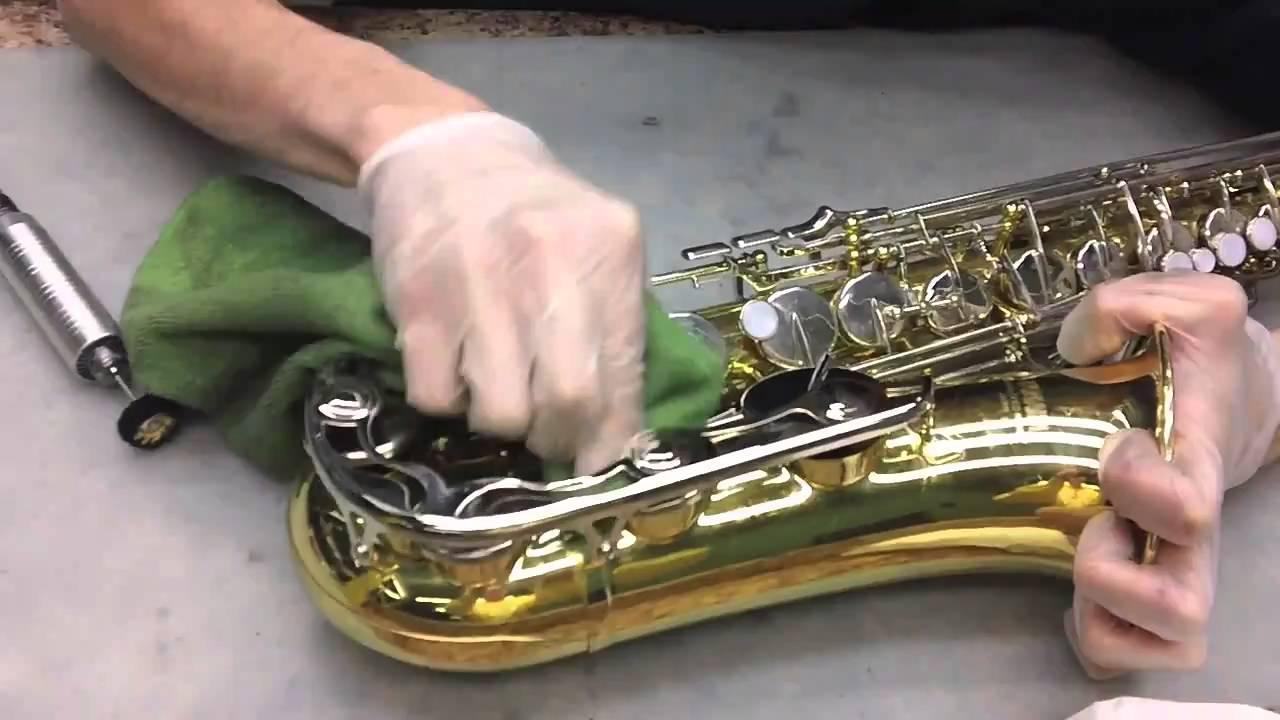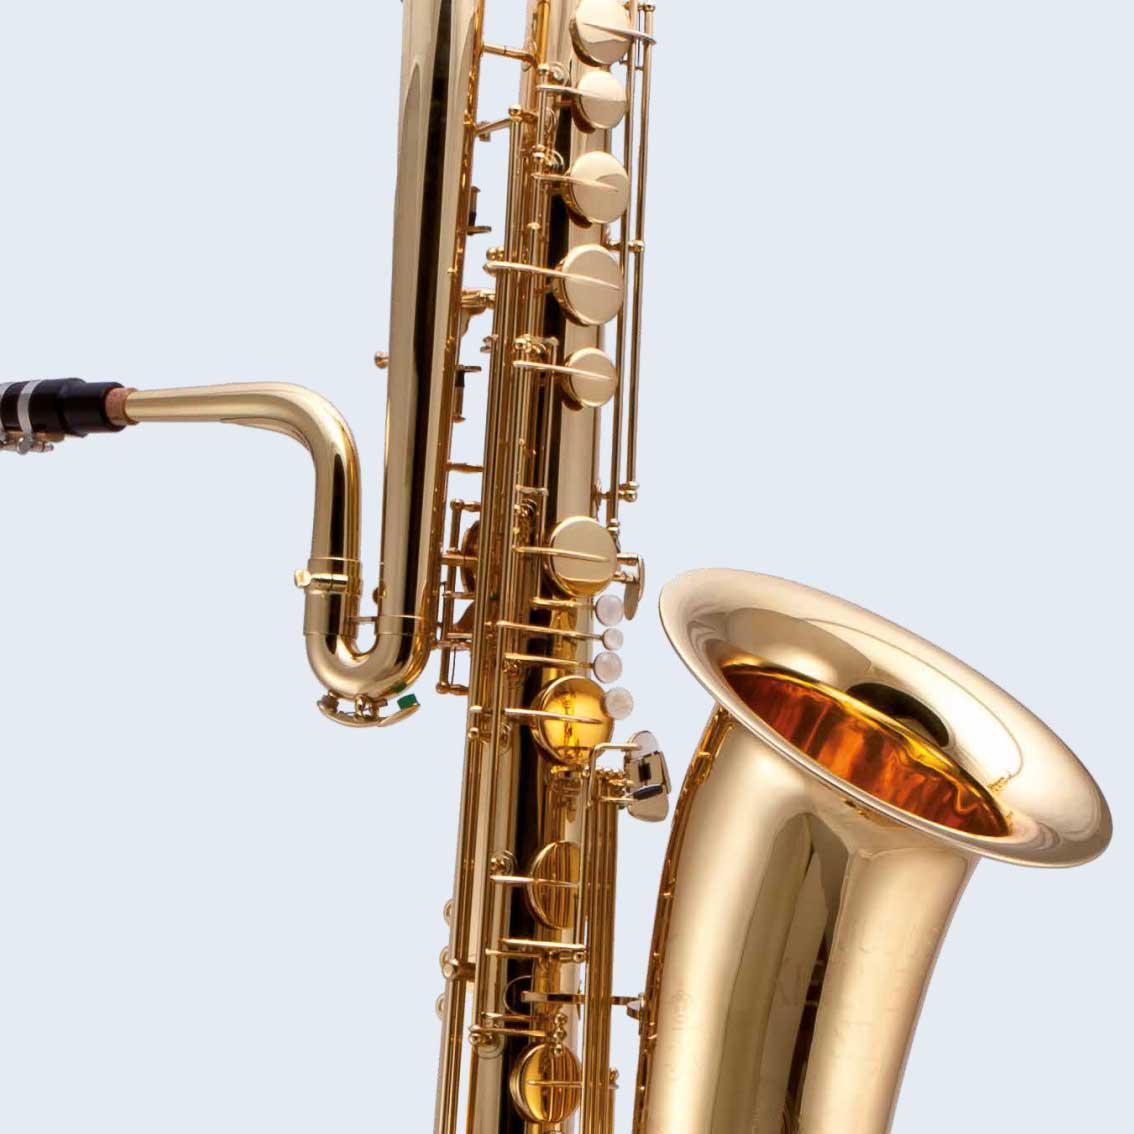The first image is the image on the left, the second image is the image on the right. Evaluate the accuracy of this statement regarding the images: "The left image contains a human touching a saxophone.". Is it true? Answer yes or no. Yes. 